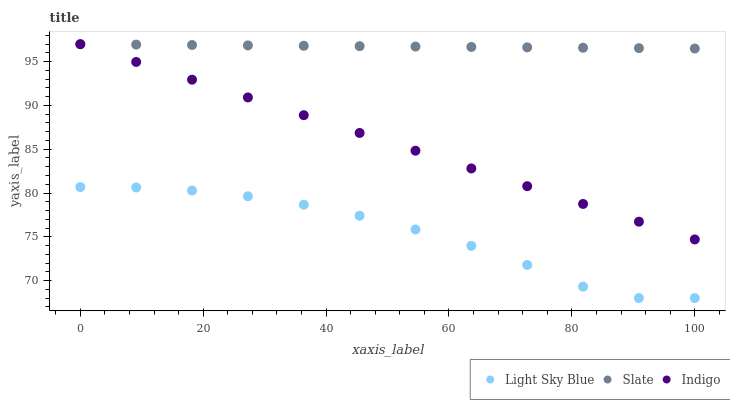Does Light Sky Blue have the minimum area under the curve?
Answer yes or no. Yes. Does Slate have the maximum area under the curve?
Answer yes or no. Yes. Does Indigo have the minimum area under the curve?
Answer yes or no. No. Does Indigo have the maximum area under the curve?
Answer yes or no. No. Is Slate the smoothest?
Answer yes or no. Yes. Is Light Sky Blue the roughest?
Answer yes or no. Yes. Is Indigo the smoothest?
Answer yes or no. No. Is Indigo the roughest?
Answer yes or no. No. Does Light Sky Blue have the lowest value?
Answer yes or no. Yes. Does Indigo have the lowest value?
Answer yes or no. No. Does Indigo have the highest value?
Answer yes or no. Yes. Does Light Sky Blue have the highest value?
Answer yes or no. No. Is Light Sky Blue less than Slate?
Answer yes or no. Yes. Is Slate greater than Light Sky Blue?
Answer yes or no. Yes. Does Indigo intersect Slate?
Answer yes or no. Yes. Is Indigo less than Slate?
Answer yes or no. No. Is Indigo greater than Slate?
Answer yes or no. No. Does Light Sky Blue intersect Slate?
Answer yes or no. No. 